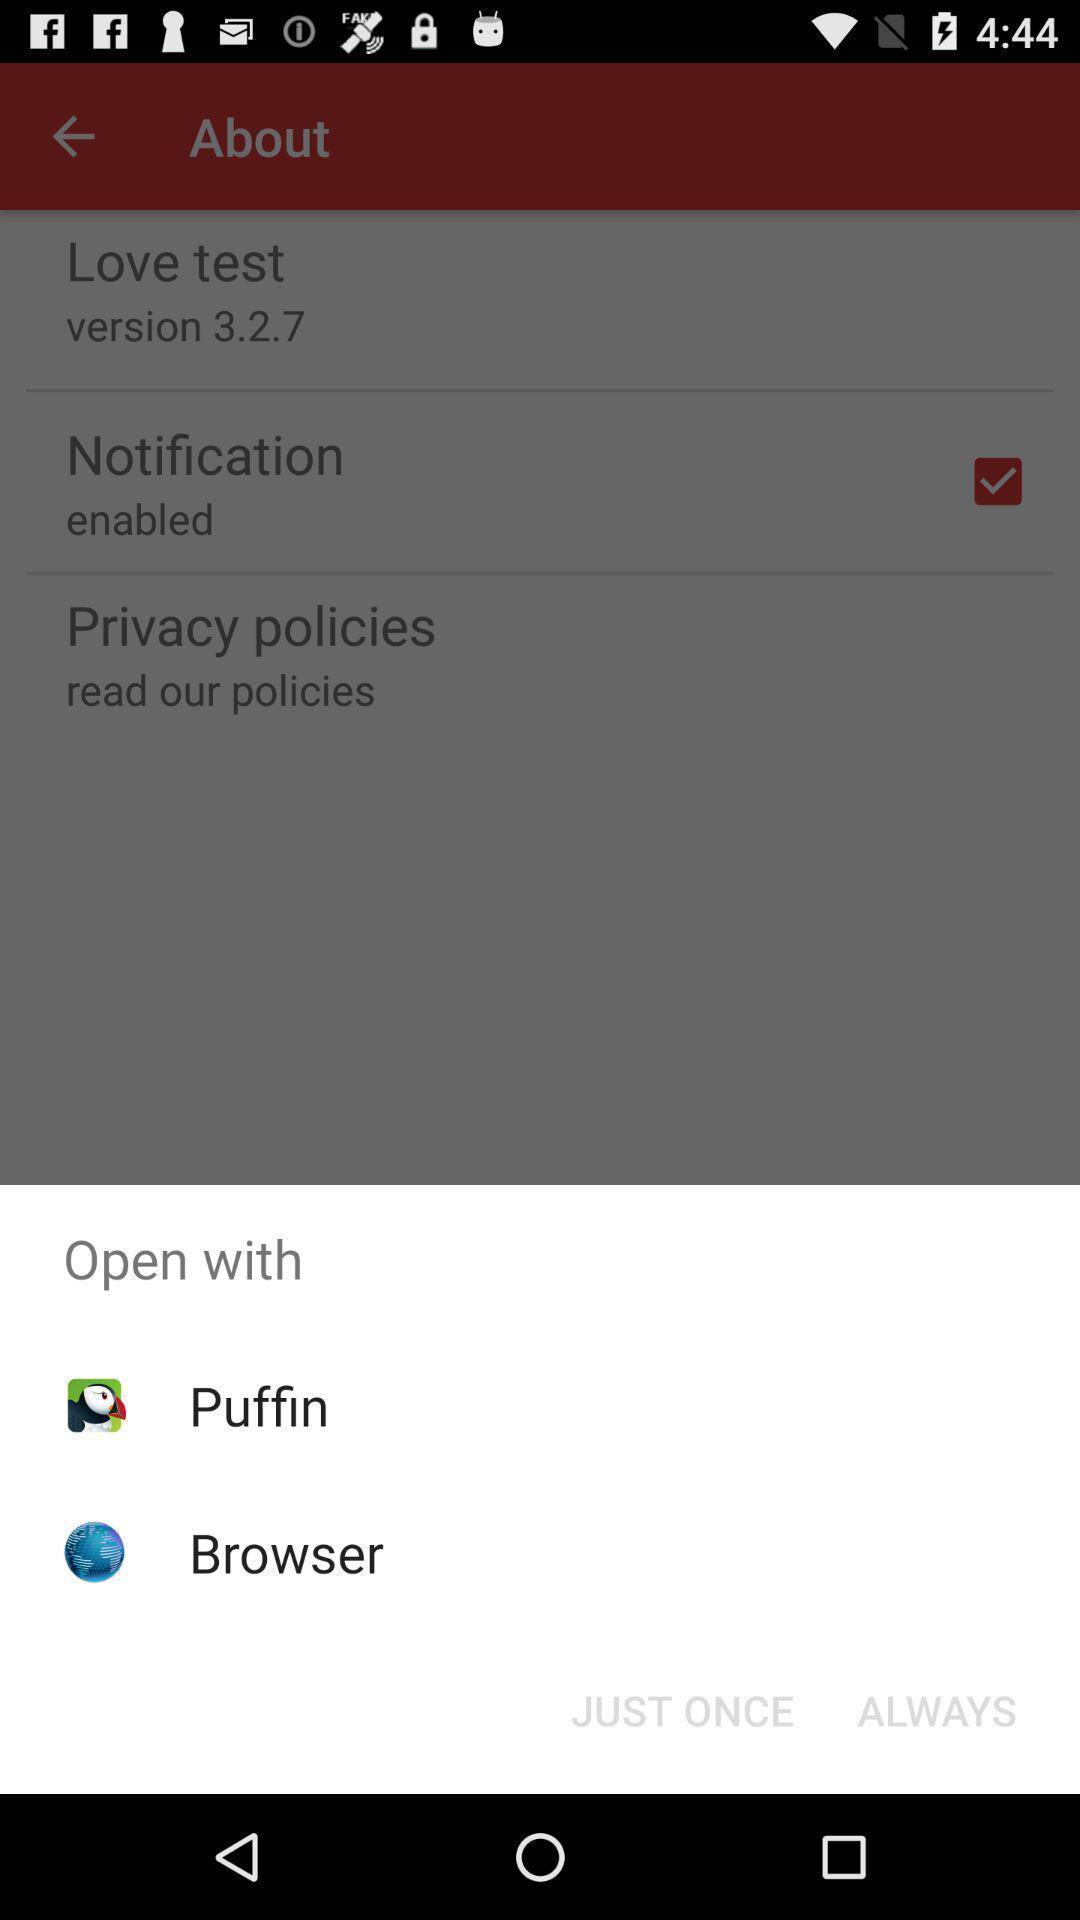Summarize the information in this screenshot. Popup showing few options with icons in an adult app. 